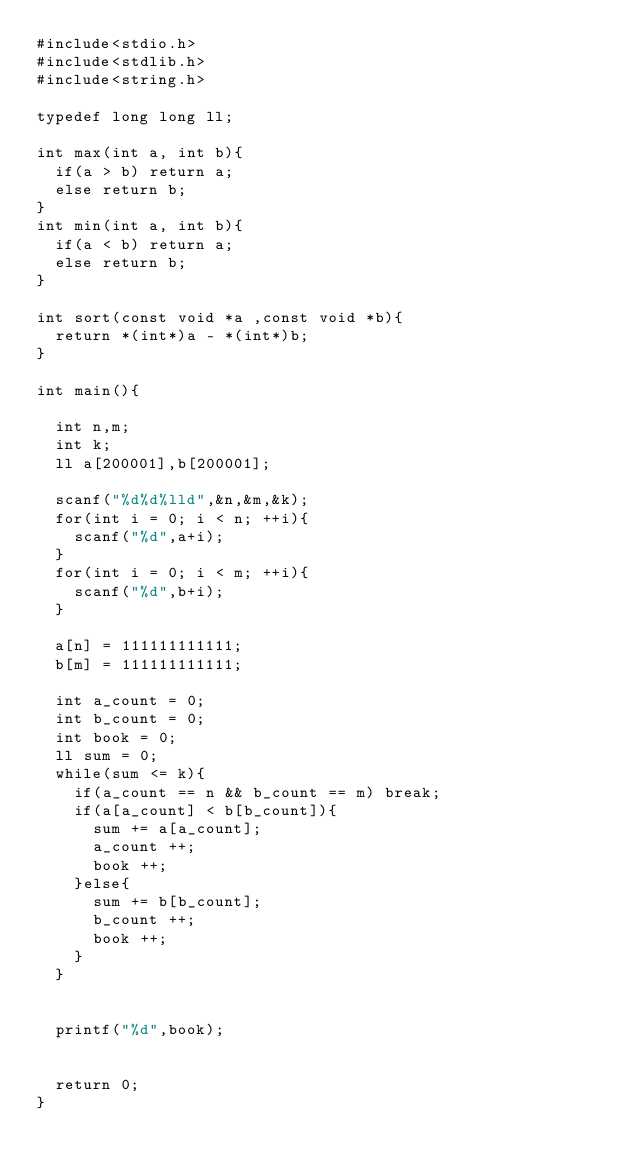Convert code to text. <code><loc_0><loc_0><loc_500><loc_500><_C_>#include<stdio.h>
#include<stdlib.h>
#include<string.h>

typedef long long ll;

int max(int a, int b){
  if(a > b) return a;
  else return b;
}
int min(int a, int b){
  if(a < b) return a;
  else return b;
}

int sort(const void *a ,const void *b){
  return *(int*)a - *(int*)b;
}

int main(){

  int n,m;
  int k;
  ll a[200001],b[200001];

  scanf("%d%d%lld",&n,&m,&k);
  for(int i = 0; i < n; ++i){
    scanf("%d",a+i);
  }
  for(int i = 0; i < m; ++i){
    scanf("%d",b+i);
  }

  a[n] = 111111111111;
  b[m] = 111111111111;

  int a_count = 0;
  int b_count = 0;
  int book = 0;
  ll sum = 0;
  while(sum <= k){
    if(a_count == n && b_count == m) break;
    if(a[a_count] < b[b_count]){
      sum += a[a_count];
      a_count ++;
      book ++;
    }else{
      sum += b[b_count];
      b_count ++;
      book ++;
    }
  }


  printf("%d",book);


  return 0;
}
</code> 